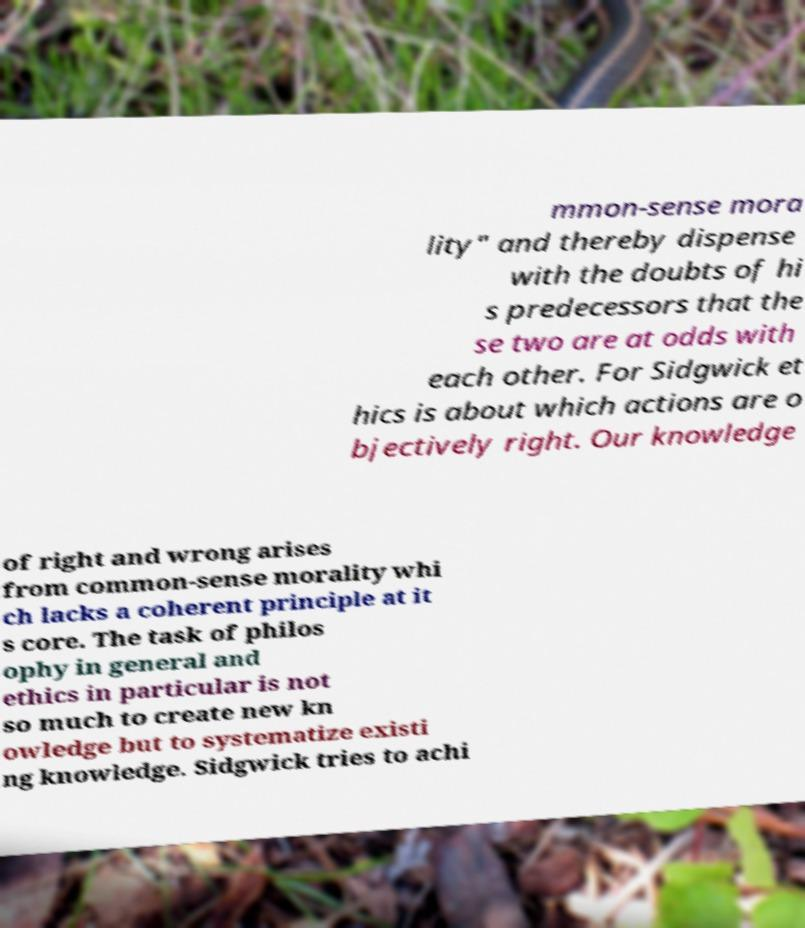Can you read and provide the text displayed in the image?This photo seems to have some interesting text. Can you extract and type it out for me? mmon-sense mora lity" and thereby dispense with the doubts of hi s predecessors that the se two are at odds with each other. For Sidgwick et hics is about which actions are o bjectively right. Our knowledge of right and wrong arises from common-sense morality whi ch lacks a coherent principle at it s core. The task of philos ophy in general and ethics in particular is not so much to create new kn owledge but to systematize existi ng knowledge. Sidgwick tries to achi 